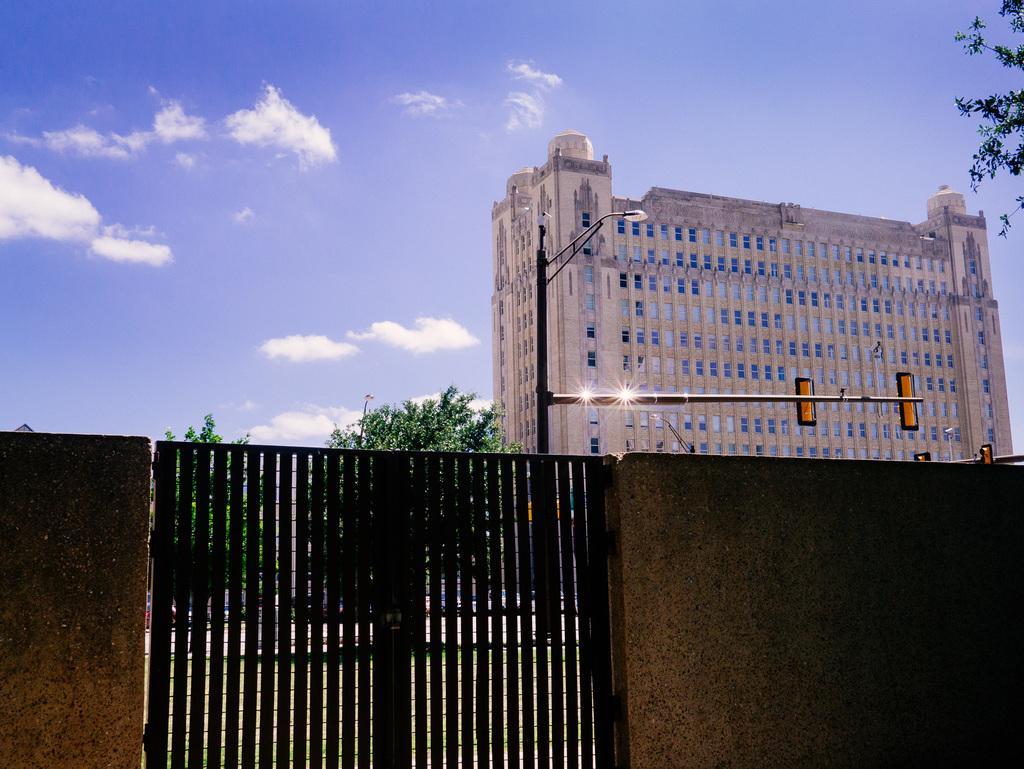In one or two sentences, can you explain what this image depicts? At the bottom of the picture, we see a wall and a black gate. Behind that, there are trees and we see a traffic signals and street lights. Behind that, we see a white building. At the top of the picture, we see the sky and the clouds. This picture is clicked outside the city. 